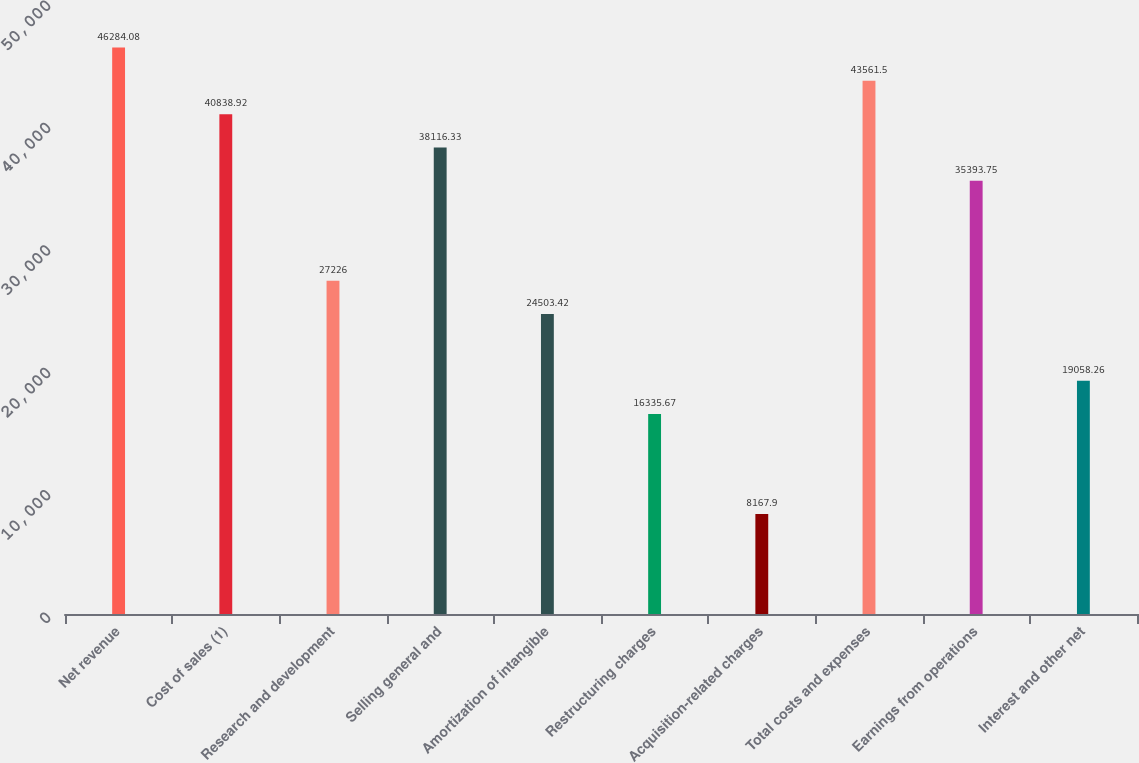Convert chart. <chart><loc_0><loc_0><loc_500><loc_500><bar_chart><fcel>Net revenue<fcel>Cost of sales (1)<fcel>Research and development<fcel>Selling general and<fcel>Amortization of intangible<fcel>Restructuring charges<fcel>Acquisition-related charges<fcel>Total costs and expenses<fcel>Earnings from operations<fcel>Interest and other net<nl><fcel>46284.1<fcel>40838.9<fcel>27226<fcel>38116.3<fcel>24503.4<fcel>16335.7<fcel>8167.9<fcel>43561.5<fcel>35393.8<fcel>19058.3<nl></chart> 